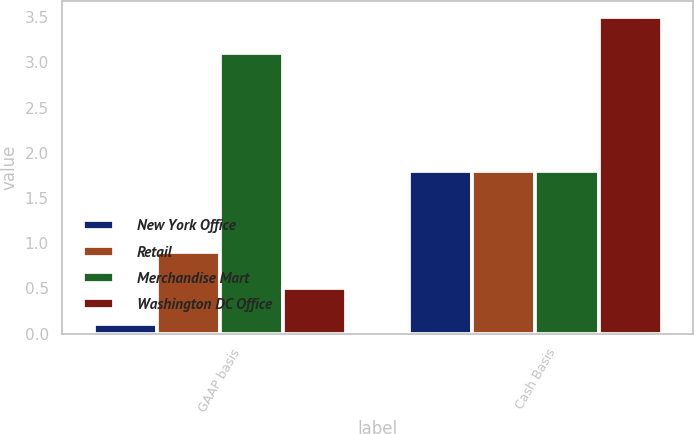<chart> <loc_0><loc_0><loc_500><loc_500><stacked_bar_chart><ecel><fcel>GAAP basis<fcel>Cash Basis<nl><fcel>New York Office<fcel>0.1<fcel>1.8<nl><fcel>Retail<fcel>0.9<fcel>1.8<nl><fcel>Merchandise Mart<fcel>3.1<fcel>1.8<nl><fcel>Washington DC Office<fcel>0.5<fcel>3.5<nl></chart> 